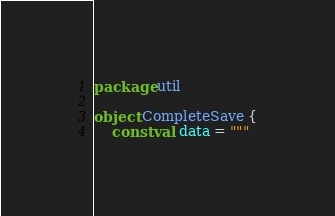Convert code to text. <code><loc_0><loc_0><loc_500><loc_500><_Kotlin_>package util

object CompleteSave {
    const val data = """</code> 